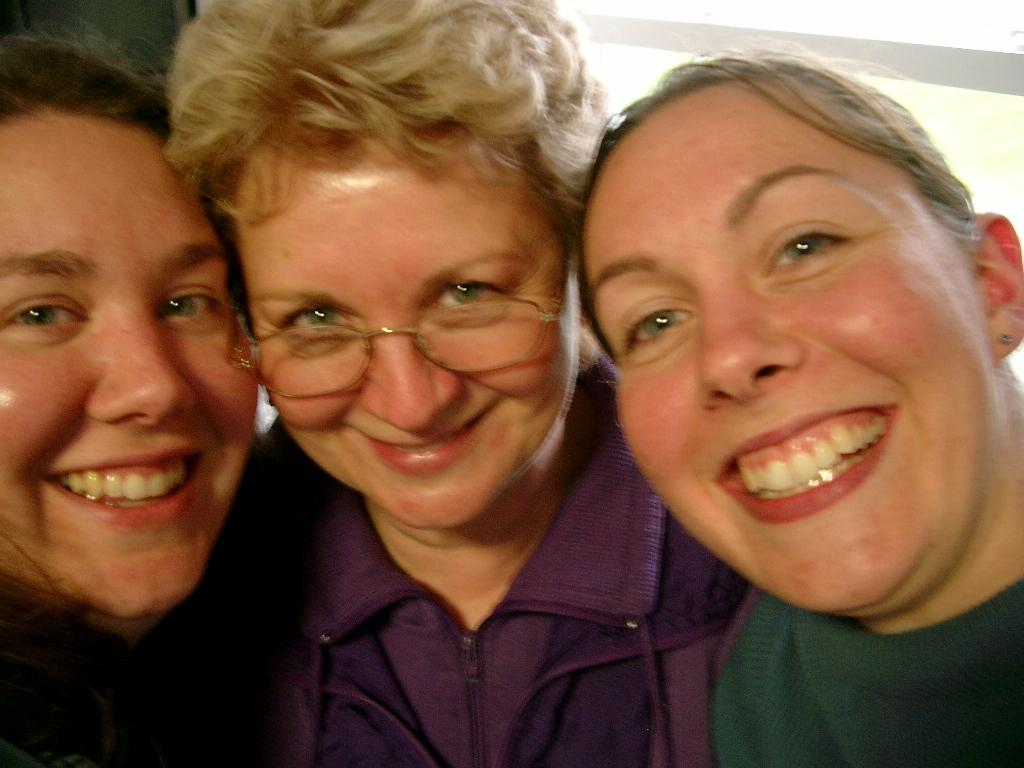How many people are in the image? There are three women in the image. What are the women doing in the image? The women are standing. What is the facial expression of the women in the image? The women are smiling. How many tomatoes can be seen in the image? There are no tomatoes present in the image. What type of ray is visible in the image? There is no ray present in the image. 